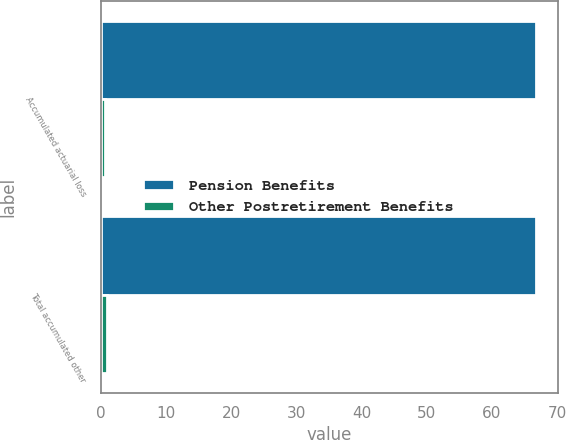<chart> <loc_0><loc_0><loc_500><loc_500><stacked_bar_chart><ecel><fcel>Accumulated actuarial loss<fcel>Total accumulated other<nl><fcel>Pension Benefits<fcel>66.8<fcel>66.8<nl><fcel>Other Postretirement Benefits<fcel>0.6<fcel>1<nl></chart> 